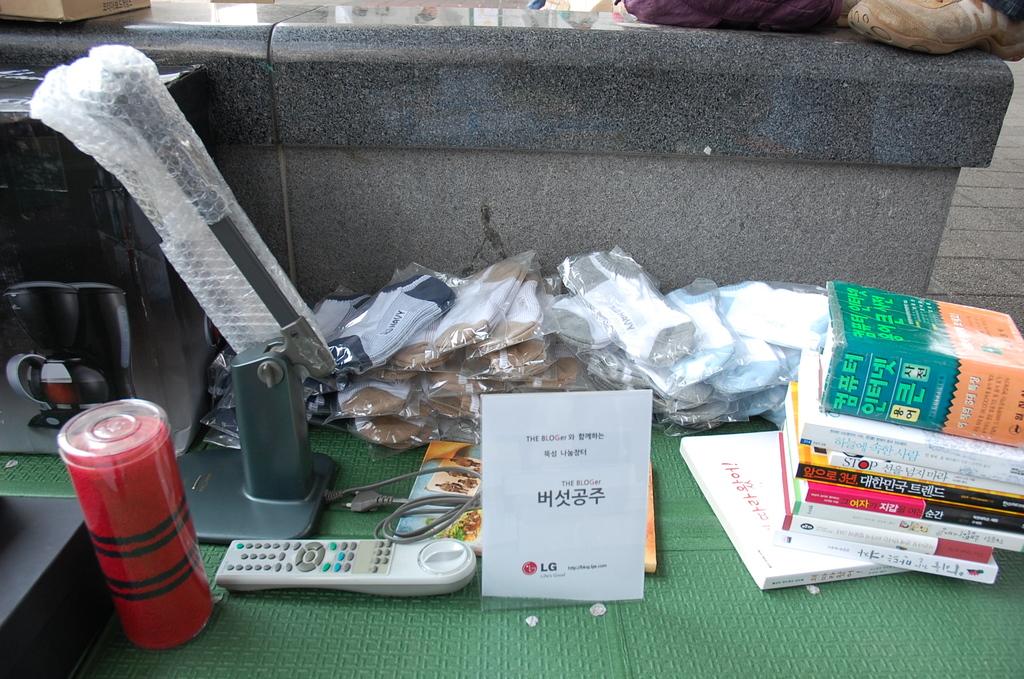What brand of manual is shown?
Provide a succinct answer. Lg. 